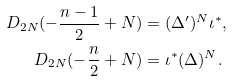<formula> <loc_0><loc_0><loc_500><loc_500>D _ { 2 N } ( - \frac { n - 1 } { 2 } + N ) & = ( \Delta ^ { \prime } ) ^ { N } \iota ^ { * } , \\ D _ { 2 N } ( - \frac { n } { 2 } + N ) & = \iota ^ { * } ( \Delta ) ^ { N } .</formula> 